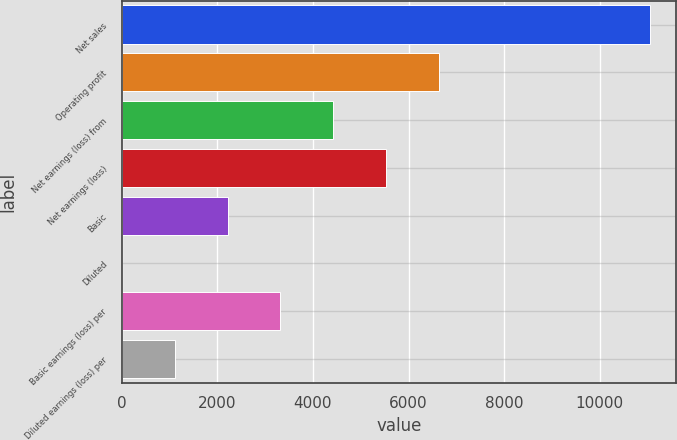Convert chart to OTSL. <chart><loc_0><loc_0><loc_500><loc_500><bar_chart><fcel>Net sales<fcel>Operating profit<fcel>Net earnings (loss) from<fcel>Net earnings (loss)<fcel>Basic<fcel>Diluted<fcel>Basic earnings (loss) per<fcel>Diluted earnings (loss) per<nl><fcel>11057<fcel>6635.25<fcel>4424.37<fcel>5529.81<fcel>2213.49<fcel>2.61<fcel>3318.93<fcel>1108.05<nl></chart> 